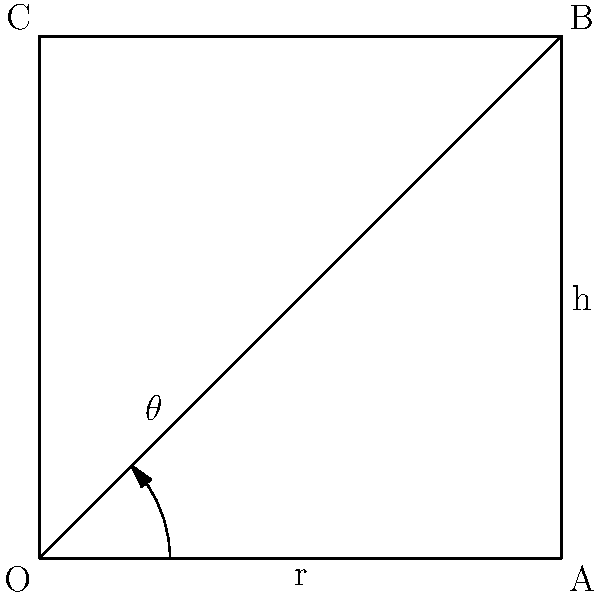In a spinning cycle, the resistance level is determined by the angle of rotation of an internal mechanism. The mechanism is represented by a square with side length $r = 2$ units. If the resistance level is proportional to the height $h$ of point B from the base, and the target resistance requires $h = \sqrt{2}$ units, what angle $\theta$ (in degrees) should the mechanism be rotated? Let's approach this step-by-step:

1) We have a square with side length $r = 2$ units.

2) The height $h$ is given as $\sqrt{2}$ units.

3) In this scenario, we have a right triangle OAB, where:
   - OA is the radius (r = 2)
   - AB is the height (h = $\sqrt{2}$)
   - OB is the hypotenuse

4) We can use the trigonometric ratio sine to find the angle $\theta$:

   $\sin \theta = \frac{\text{opposite}}{\text{hypotenuse}} = \frac{h}{r}$

5) Substituting the known values:

   $\sin \theta = \frac{\sqrt{2}}{2}$

6) To find $\theta$, we need to take the inverse sine (arcsin):

   $\theta = \arcsin(\frac{\sqrt{2}}{2})$

7) Calculating this:
   
   $\theta \approx 45°$

Therefore, the mechanism should be rotated by approximately 45 degrees to achieve the target resistance level.
Answer: $45°$ 